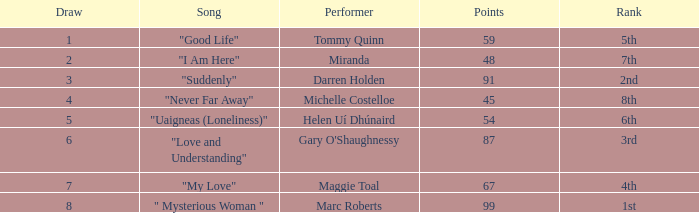What is the average number of points for a song ranked 2nd with a draw greater than 3? None. 